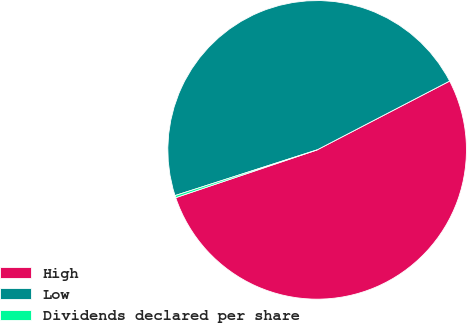Convert chart to OTSL. <chart><loc_0><loc_0><loc_500><loc_500><pie_chart><fcel>High<fcel>Low<fcel>Dividends declared per share<nl><fcel>52.43%<fcel>47.33%<fcel>0.23%<nl></chart> 